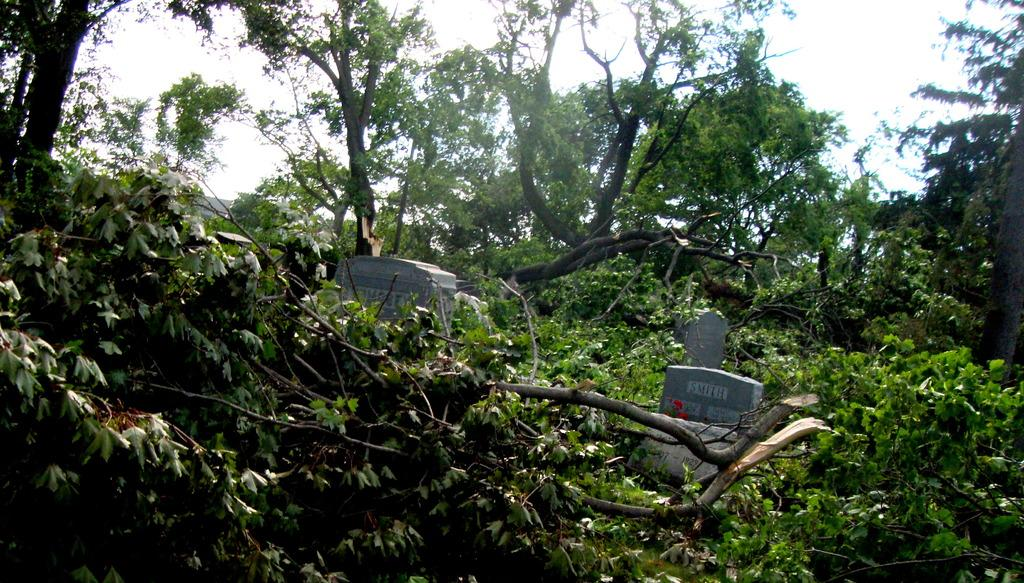What type of vegetation can be seen in the image? There are trees in the image. What type of structures are present in the image? There are graves in the image. What is visible in the background of the image? The sky is visible in the image. Can you find the receipt for the plant purchase in the image? There is no receipt or plant purchase present in the image. Where is the boot located in the image? There is no boot present in the image. 